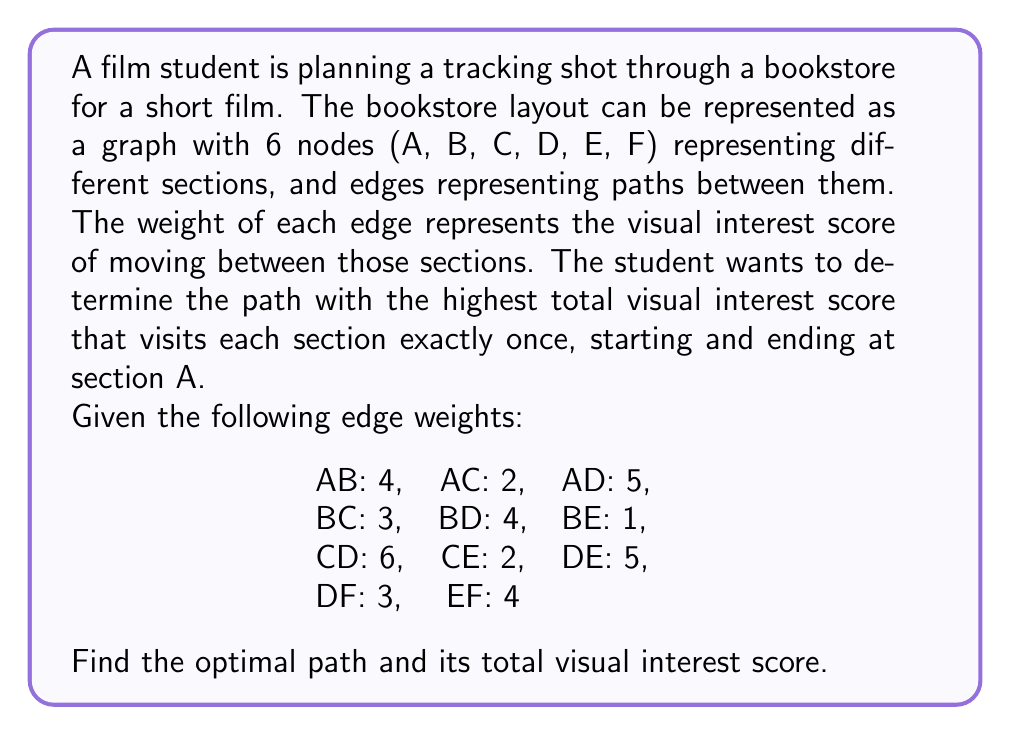Help me with this question. To solve this problem, we need to find the Hamiltonian cycle with the maximum weight in the given graph. This is similar to the Traveling Salesman Problem, but we're maximizing the total weight instead of minimizing it.

Step 1: Identify all possible Hamiltonian cycles starting and ending at A.
There are $(6-1)! = 5! = 120$ possible paths, but we can reduce this by considering symmetry.

Step 2: Calculate the total weight for each possible path.
Let's consider some of the possible paths:

1. A-B-C-D-E-F-A: $4 + 3 + 6 + 5 + 4 + 5 = 27$
2. A-B-C-E-D-F-A: $4 + 3 + 2 + 5 + 3 + 5 = 22$
3. A-B-D-C-E-F-A: $4 + 4 + 6 + 2 + 4 + 5 = 25$
4. A-B-E-C-D-F-A: $4 + 1 + 2 + 6 + 3 + 5 = 21$
5. A-C-B-D-E-F-A: $2 + 3 + 4 + 5 + 4 + 5 = 23$
6. A-C-D-B-E-F-A: $2 + 6 + 4 + 1 + 4 + 5 = 22$
7. A-C-E-B-D-F-A: $2 + 2 + 1 + 4 + 3 + 5 = 17$
8. A-D-B-C-E-F-A: $5 + 4 + 3 + 2 + 4 + 5 = 23$
9. A-D-C-B-E-F-A: $5 + 6 + 3 + 1 + 4 + 5 = 24$
10. A-D-E-C-B-F-A: $5 + 5 + 2 + 3 + 1 + 5 = 21$

Step 3: Identify the path with the highest total weight.
From the calculations above, we can see that the path A-B-C-D-E-F-A has the highest total weight of 27.

Step 4: Verify that this is indeed the optimal path by checking if any other combination could potentially yield a higher score.
Given the edge weights, it's clear that this path includes some of the highest-weighted edges (AD: 5, CD: 6, DE: 5) while still forming a valid Hamiltonian cycle. No other combination of edges can produce a higher total weight while still forming a valid cycle.
Answer: The optimal path is A-B-C-D-E-F-A with a total visual interest score of 27. 